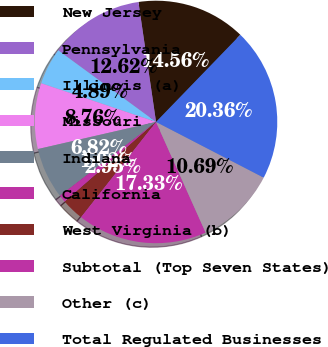Convert chart. <chart><loc_0><loc_0><loc_500><loc_500><pie_chart><fcel>New Jersey<fcel>Pennsylvania<fcel>Illinois (a)<fcel>Missouri<fcel>Indiana<fcel>California<fcel>West Virginia (b)<fcel>Subtotal (Top Seven States)<fcel>Other (c)<fcel>Total Regulated Businesses<nl><fcel>14.56%<fcel>12.62%<fcel>4.89%<fcel>8.76%<fcel>6.82%<fcel>1.02%<fcel>2.95%<fcel>17.33%<fcel>10.69%<fcel>20.36%<nl></chart> 